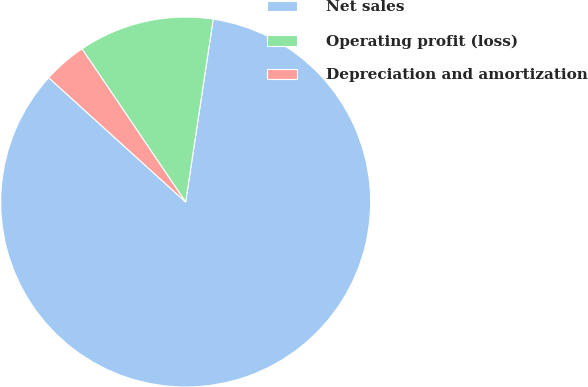<chart> <loc_0><loc_0><loc_500><loc_500><pie_chart><fcel>Net sales<fcel>Operating profit (loss)<fcel>Depreciation and amortization<nl><fcel>84.35%<fcel>11.85%<fcel>3.8%<nl></chart> 